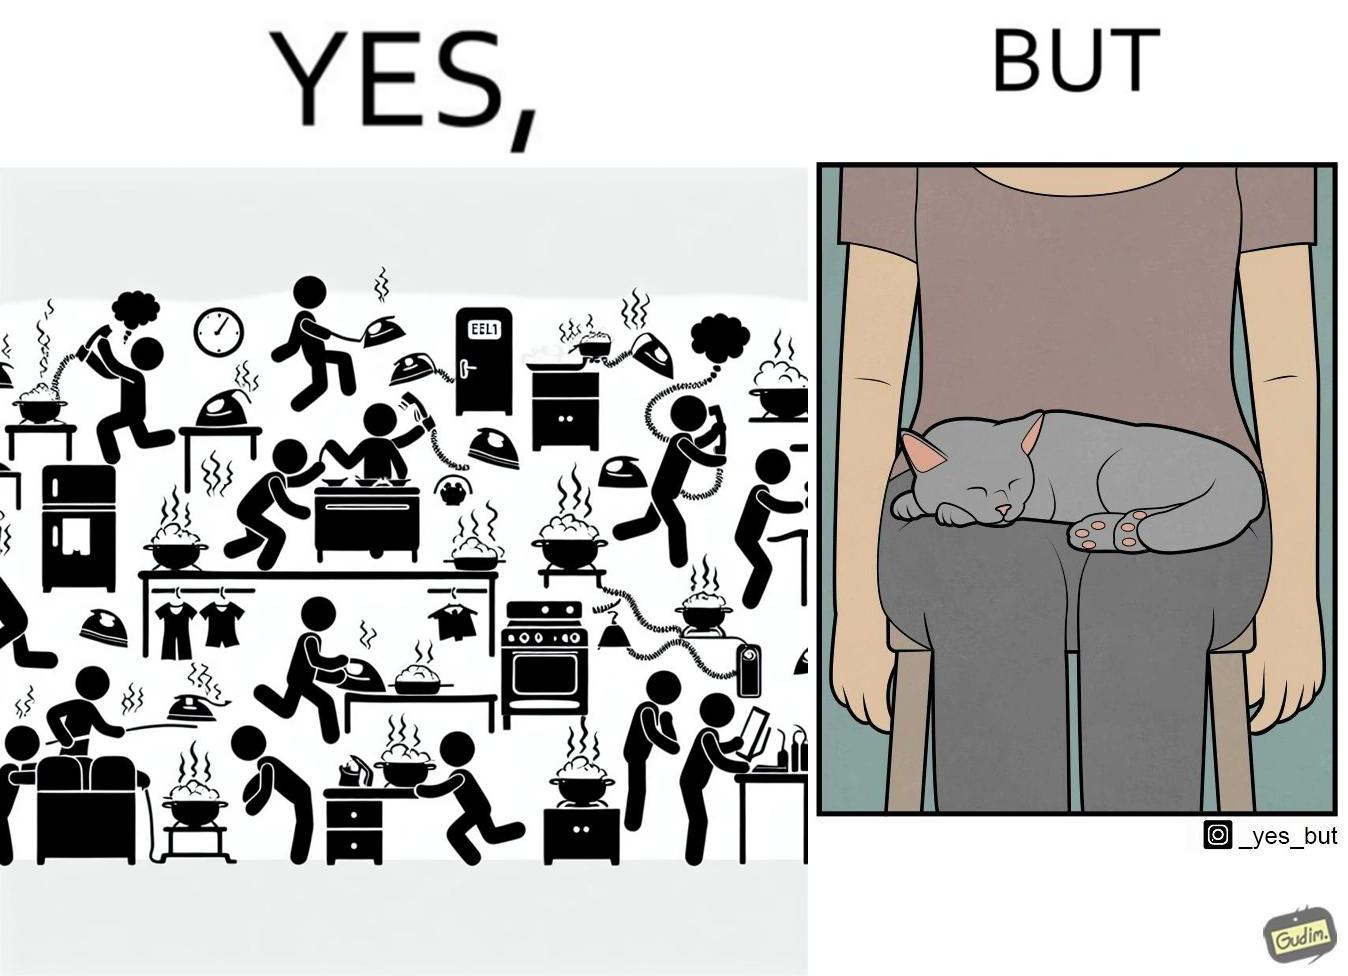Is there satirical content in this image? Yes, this image is satirical. 